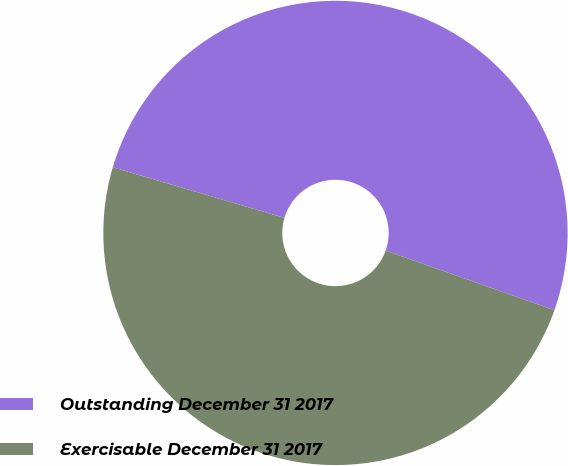<chart> <loc_0><loc_0><loc_500><loc_500><pie_chart><fcel>Outstanding December 31 2017<fcel>Exercisable December 31 2017<nl><fcel>50.83%<fcel>49.17%<nl></chart> 